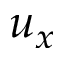Convert formula to latex. <formula><loc_0><loc_0><loc_500><loc_500>u _ { x }</formula> 